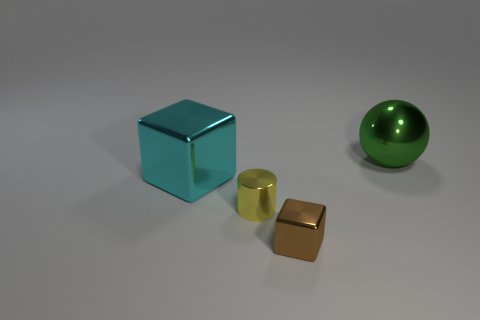Add 3 blue metal balls. How many objects exist? 7 Subtract all balls. How many objects are left? 3 Add 3 small yellow metallic cylinders. How many small yellow metallic cylinders exist? 4 Subtract 0 gray cylinders. How many objects are left? 4 Subtract all big spheres. Subtract all large green metallic objects. How many objects are left? 2 Add 3 large green metal objects. How many large green metal objects are left? 4 